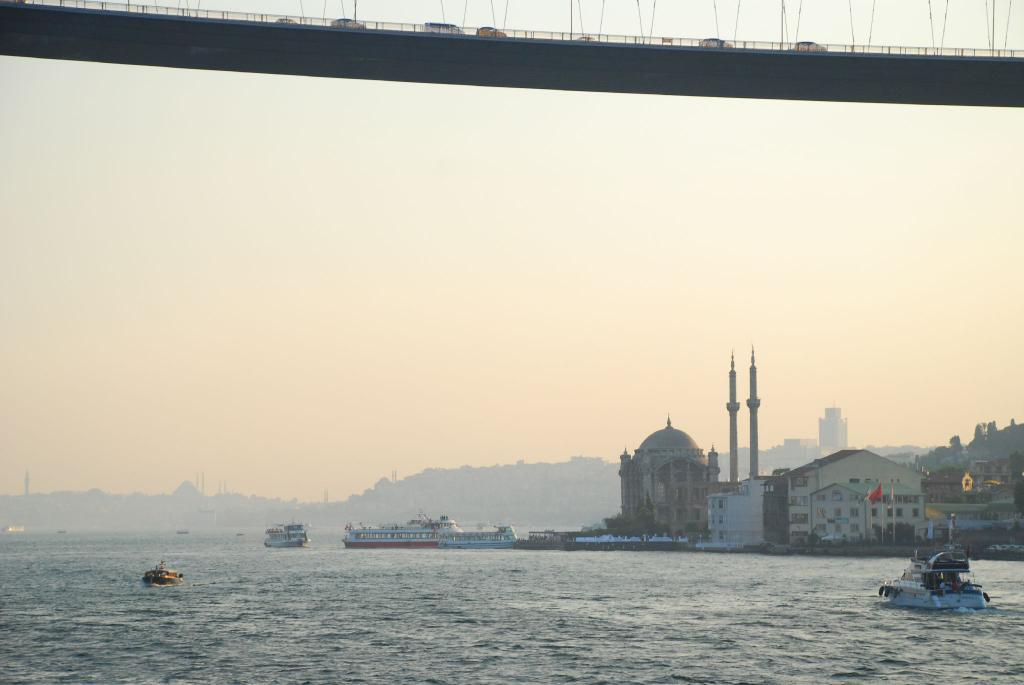What is in the water in the image? There are boats in the water in the image. What can be seen in the background of the image? There are buildings and the sky visible in the background. What connects the two sides of the water in the image? There is a bridge in the image. Where are the oranges hanging in the image? There are no oranges present in the image. Can you describe the friends sitting on the bridge in the image? There are no friends or any people sitting on the bridge in the image. 